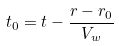<formula> <loc_0><loc_0><loc_500><loc_500>t _ { 0 } = t - \frac { r - r _ { 0 } } { V _ { w } }</formula> 